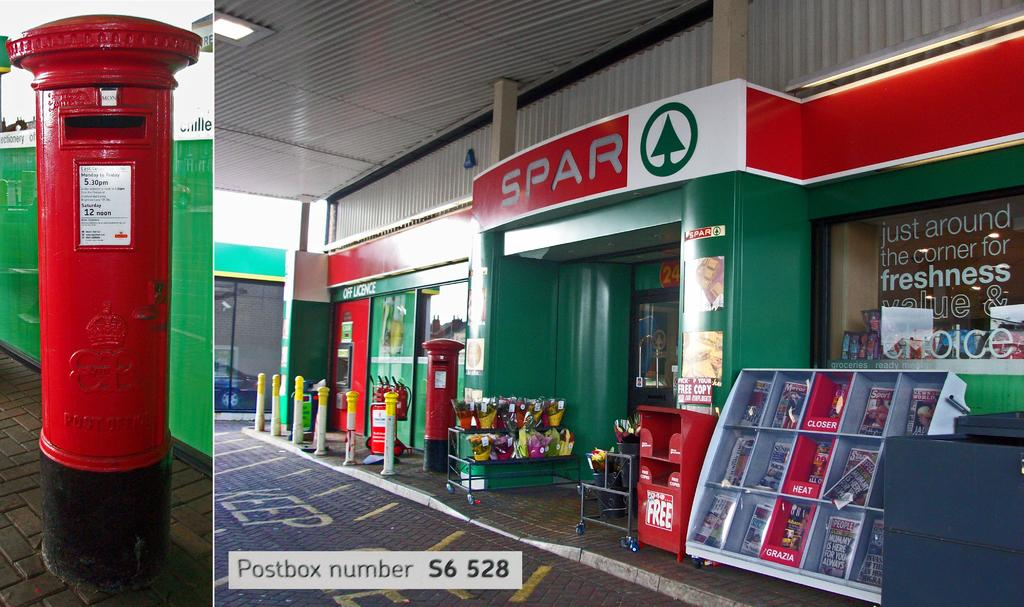<image>
Relay a brief, clear account of the picture shown. the store front of a Spar store painted green and red 